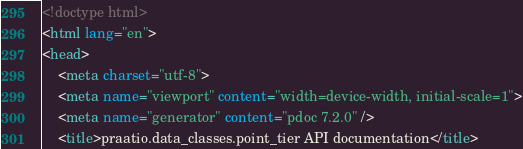Convert code to text. <code><loc_0><loc_0><loc_500><loc_500><_HTML_><!doctype html>
<html lang="en">
<head>
    <meta charset="utf-8">
    <meta name="viewport" content="width=device-width, initial-scale=1">
    <meta name="generator" content="pdoc 7.2.0" />
    <title>praatio.data_classes.point_tier API documentation</title></code> 